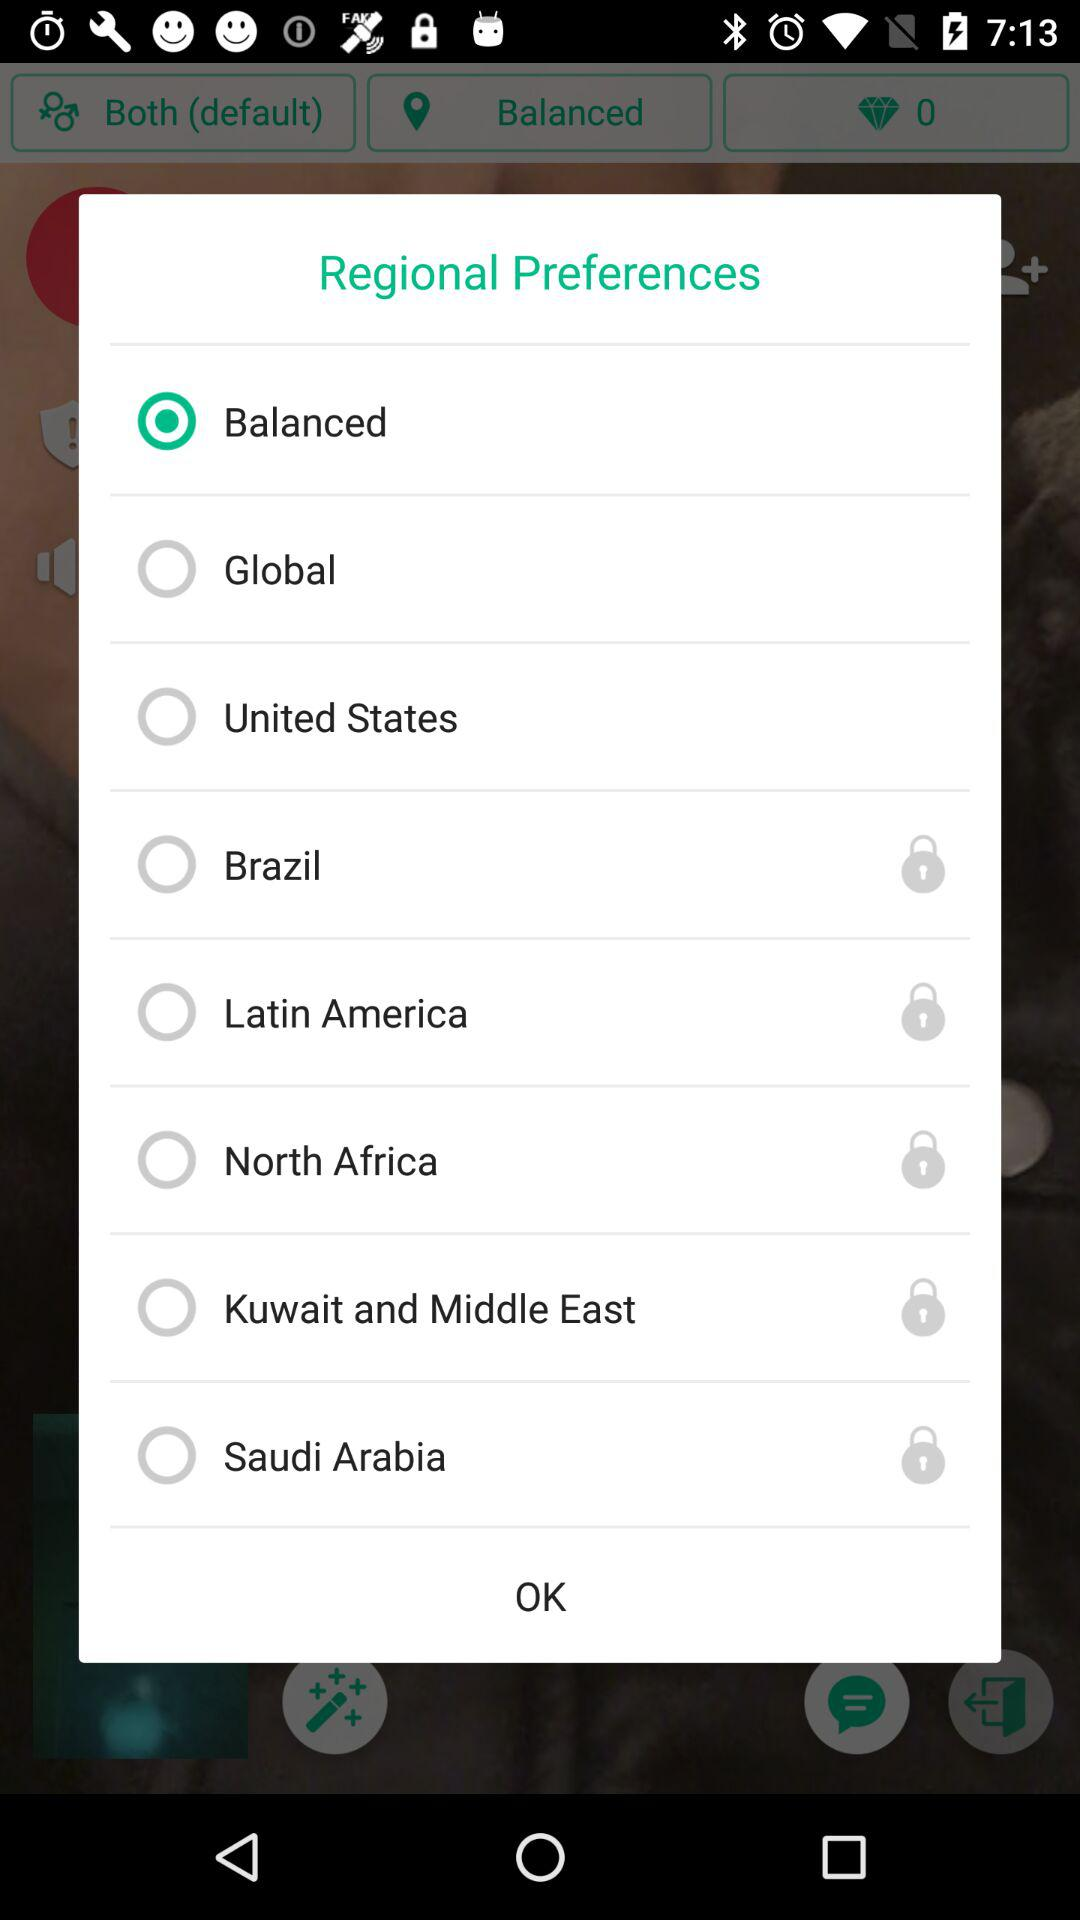What is the current status of "North Africa"?
Answer the question using a single word or phrase. It is "locked". 